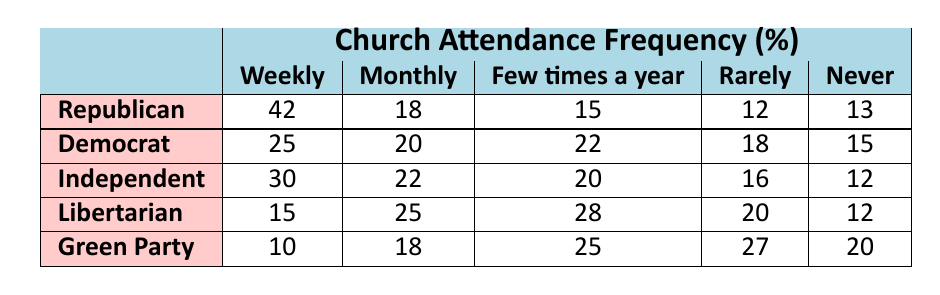What percentage of Republicans attend church weekly? According to the table, the percentage of Republicans who attend church weekly is directly listed as 42%.
Answer: 42% How many Republicans attend church rarely? From the table, the value for Republicans attending church rarely is given as 12%.
Answer: 12% Which political affiliation has the highest percentage of weekly church attendance? By comparing the weekly attendance percentages, Republicans have the highest at 42%, followed by Independents with 30%.
Answer: Republicans What is the total percentage of Democrats who attend church at least monthly? To find this, add the percentages of Democrats who attend weekly (25%) and monthly (20%), which totals 25% + 20% = 45%.
Answer: 45% Do more Independents attend church monthly or rarely? Independents show a monthly attendance of 22% and a rarely attendance of 16%. Since 22% (monthly) is greater than 16% (rarely), more Independents attend monthly.
Answer: Yes What is the difference in weekly church attendance between Republicans and Democrats? Republicans attend weekly at 42%, while Democrats are at 25%. The difference is 42% - 25% = 17%.
Answer: 17% Which group has the lowest percentage of church attendance never? Looking at the table, both Republicans and Libertarians have the lowest percentage at 12%. However, Green Party has a higher number at 20%.
Answer: Republicans and Libertarians What is the average percentage of weekly church attendance across all affiliations? To find the average, sum the weekly attendance percentages of all affiliations: (42 + 25 + 30 + 15 + 10) = 122. Then divide by the number of affiliations, which is 5: 122 / 5 = 24.4%.
Answer: 24.4% Which political affiliation has the highest combined percentage of 'Never' and 'Rarely' attendance? Calculate the sums for each affiliation: Republicans (12% + 13% = 25%), Democrats (18% + 15% = 33%), Independents (16% + 12% = 28%), Libertarians (20% + 12% = 32%), Green Party (27% + 20% = 47%). Green Party is the highest.
Answer: Green Party Is there a majority of Democrats attending church at least a few times a year (monthly or more frequently)? Adding Democrats' weekly (25%) and monthly (20%) attendance gives 45%. Since 45% is less than half of 100%, it is not a majority.
Answer: No 